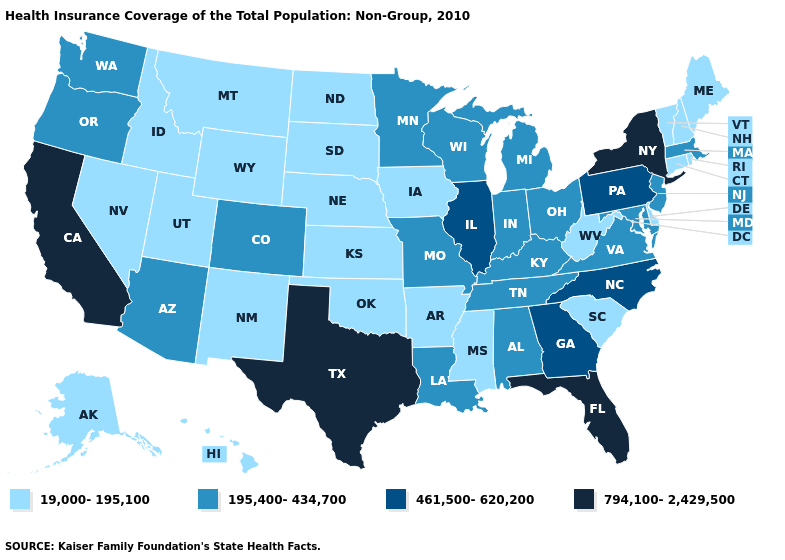Name the states that have a value in the range 195,400-434,700?
Quick response, please. Alabama, Arizona, Colorado, Indiana, Kentucky, Louisiana, Maryland, Massachusetts, Michigan, Minnesota, Missouri, New Jersey, Ohio, Oregon, Tennessee, Virginia, Washington, Wisconsin. Name the states that have a value in the range 195,400-434,700?
Quick response, please. Alabama, Arizona, Colorado, Indiana, Kentucky, Louisiana, Maryland, Massachusetts, Michigan, Minnesota, Missouri, New Jersey, Ohio, Oregon, Tennessee, Virginia, Washington, Wisconsin. Name the states that have a value in the range 461,500-620,200?
Answer briefly. Georgia, Illinois, North Carolina, Pennsylvania. Does Tennessee have a lower value than North Carolina?
Short answer required. Yes. What is the value of Louisiana?
Short answer required. 195,400-434,700. Does Oklahoma have the highest value in the South?
Be succinct. No. Name the states that have a value in the range 195,400-434,700?
Be succinct. Alabama, Arizona, Colorado, Indiana, Kentucky, Louisiana, Maryland, Massachusetts, Michigan, Minnesota, Missouri, New Jersey, Ohio, Oregon, Tennessee, Virginia, Washington, Wisconsin. Among the states that border Louisiana , which have the highest value?
Short answer required. Texas. Does California have the lowest value in the USA?
Keep it brief. No. What is the lowest value in states that border Indiana?
Quick response, please. 195,400-434,700. What is the value of Nevada?
Short answer required. 19,000-195,100. Name the states that have a value in the range 461,500-620,200?
Quick response, please. Georgia, Illinois, North Carolina, Pennsylvania. What is the value of Mississippi?
Write a very short answer. 19,000-195,100. What is the highest value in the South ?
Quick response, please. 794,100-2,429,500. What is the value of Michigan?
Be succinct. 195,400-434,700. 